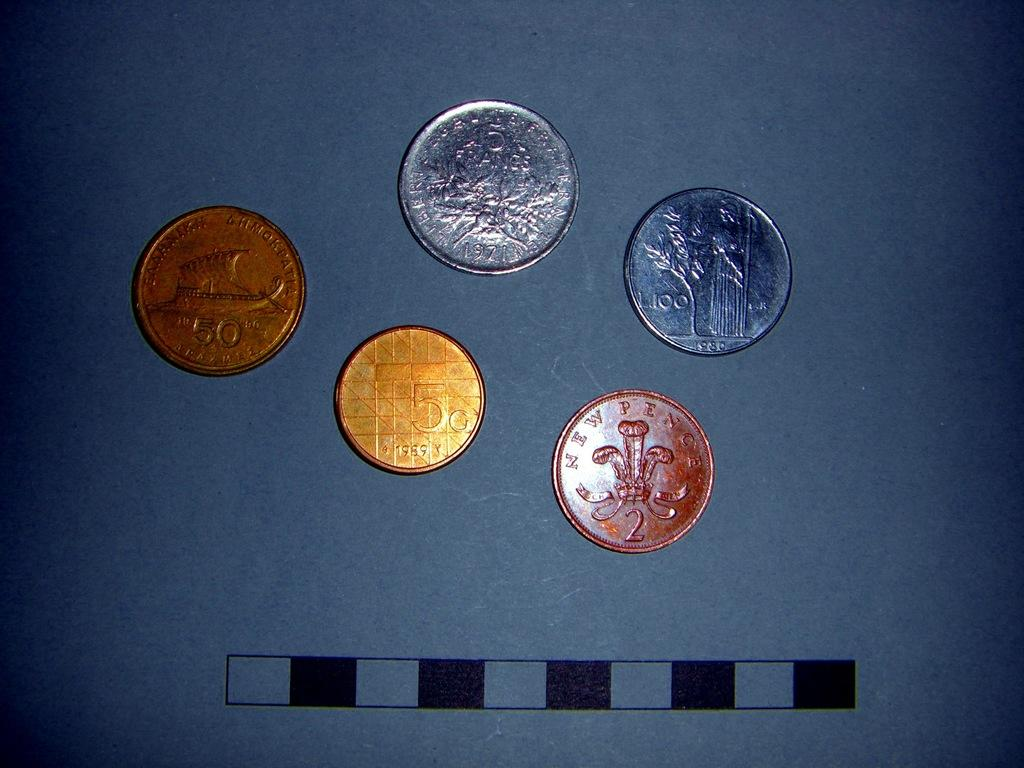Provide a one-sentence caption for the provided image. Five various colored coins including one from new pence. 